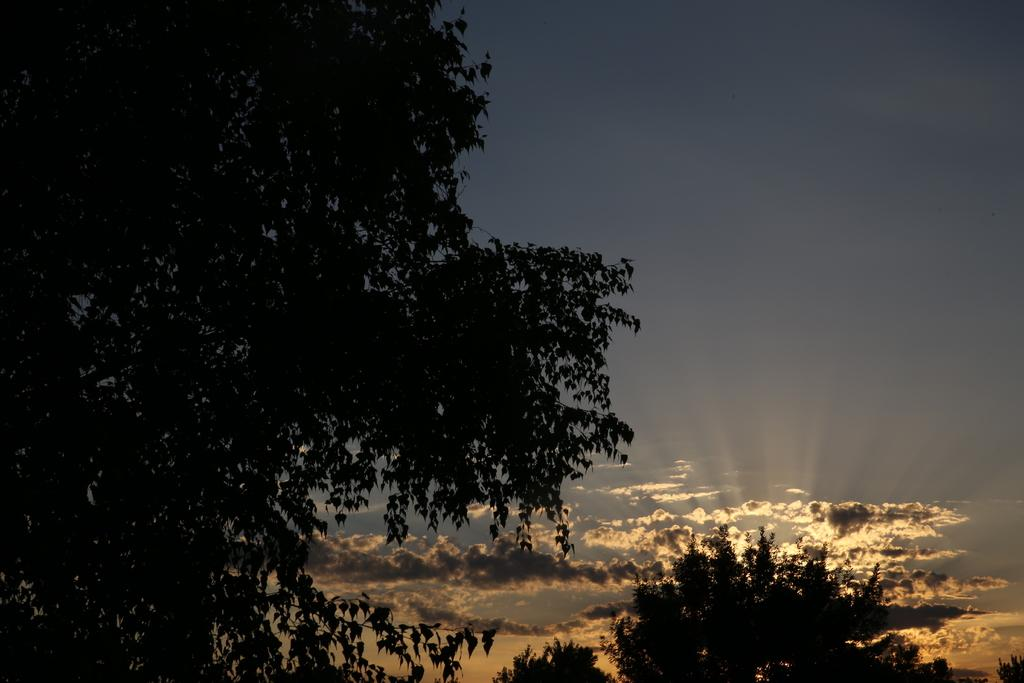What type of vegetation can be seen in the image? There are trees in the image. What is visible in the background of the image? There is sky visible in the background of the image. Are there any weather conditions depicted in the image? Yes, there are clouds in the background of the image. What type of ornament is hanging from the tree in the image? There is no ornament hanging from the tree in the image; only trees, sky, and clouds are present. Can you hear the goose coughing in the image? There is no goose or coughing sound present in the image. 